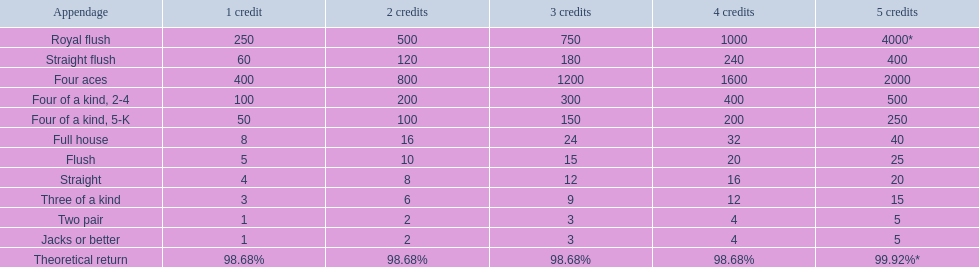Help me parse the entirety of this table. {'header': ['Appendage', '1 credit', '2 credits', '3 credits', '4 credits', '5 credits'], 'rows': [['Royal flush', '250', '500', '750', '1000', '4000*'], ['Straight flush', '60', '120', '180', '240', '400'], ['Four aces', '400', '800', '1200', '1600', '2000'], ['Four of a kind, 2-4', '100', '200', '300', '400', '500'], ['Four of a kind, 5-K', '50', '100', '150', '200', '250'], ['Full house', '8', '16', '24', '32', '40'], ['Flush', '5', '10', '15', '20', '25'], ['Straight', '4', '8', '12', '16', '20'], ['Three of a kind', '3', '6', '9', '12', '15'], ['Two pair', '1', '2', '3', '4', '5'], ['Jacks or better', '1', '2', '3', '4', '5'], ['Theoretical return', '98.68%', '98.68%', '98.68%', '98.68%', '99.92%*']]} What are the hands in super aces? Royal flush, Straight flush, Four aces, Four of a kind, 2-4, Four of a kind, 5-K, Full house, Flush, Straight, Three of a kind, Two pair, Jacks or better. What hand gives the highest credits? Royal flush. 